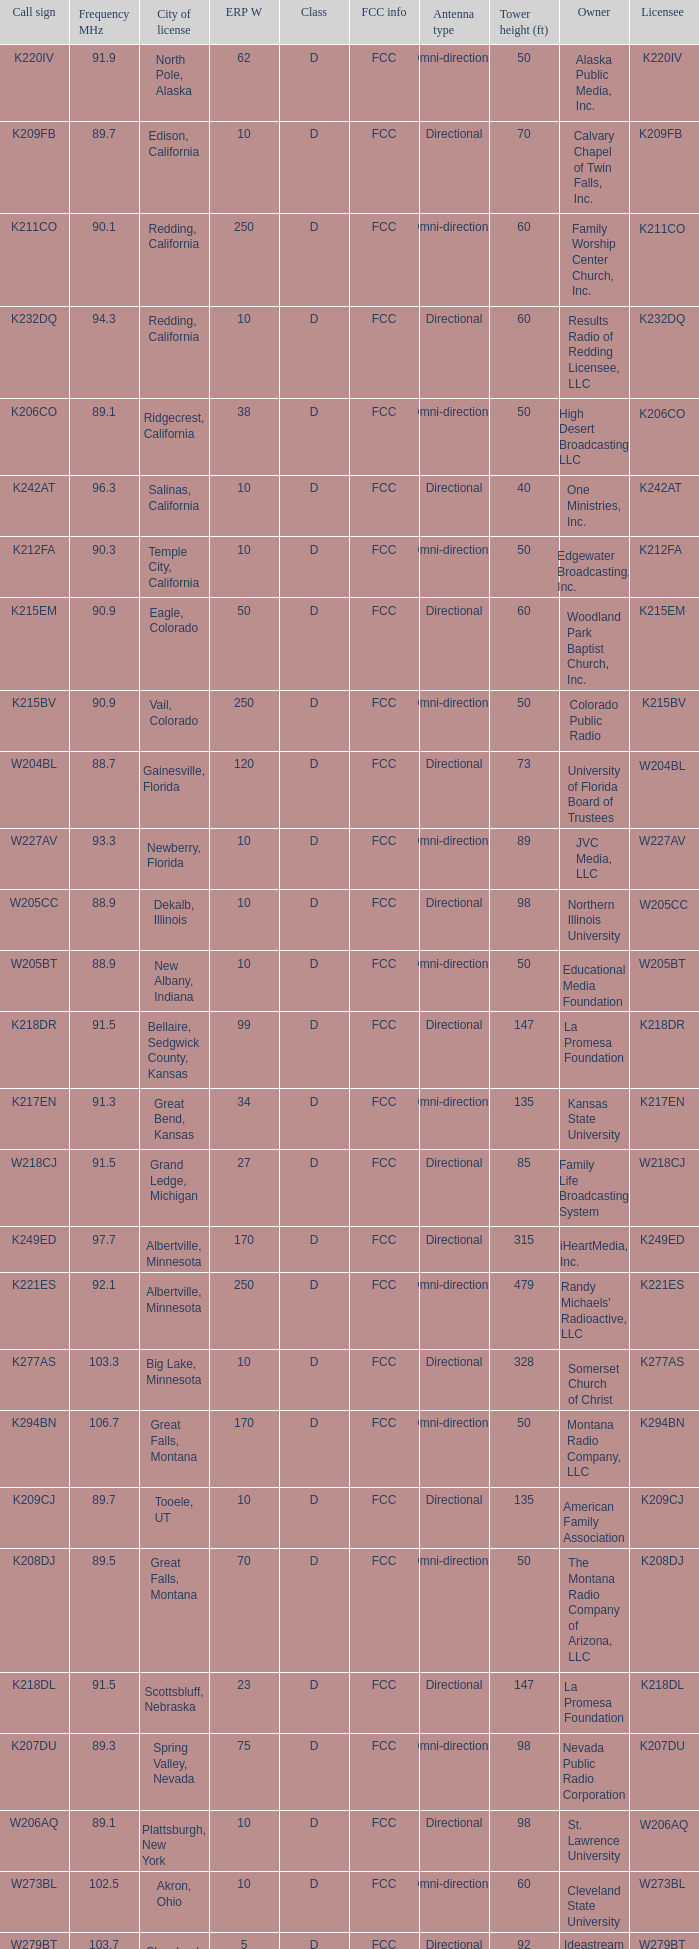What is the call sign of the translator in Spring Valley, Nevada? K207DU. 